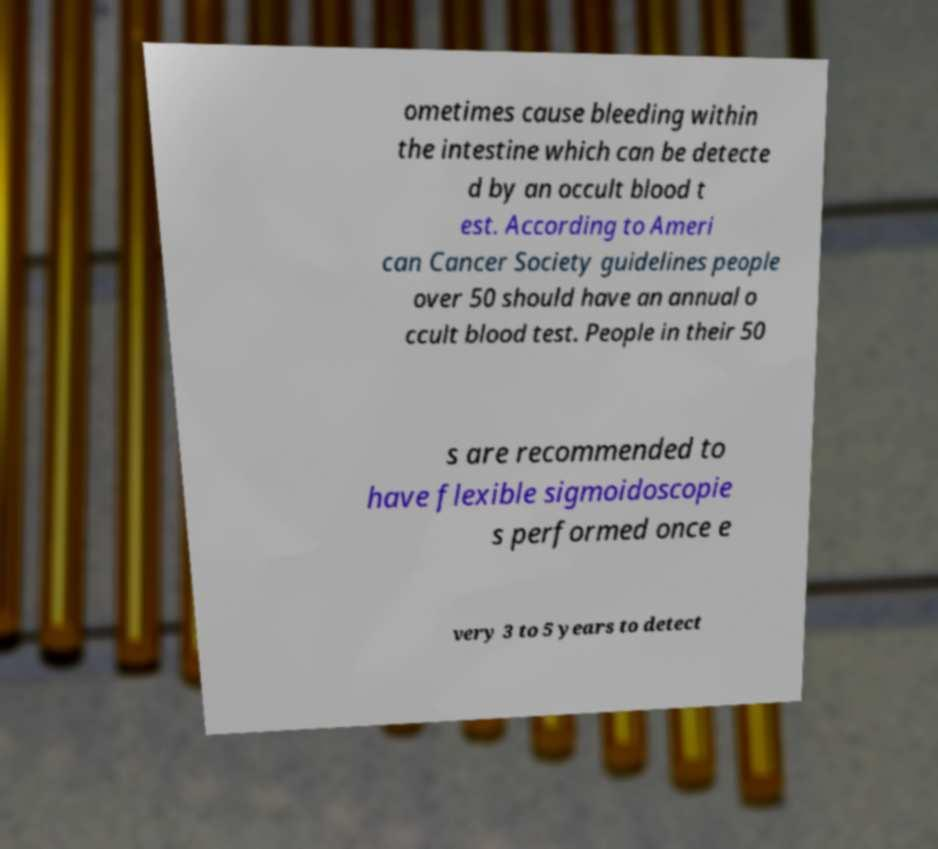For documentation purposes, I need the text within this image transcribed. Could you provide that? ometimes cause bleeding within the intestine which can be detecte d by an occult blood t est. According to Ameri can Cancer Society guidelines people over 50 should have an annual o ccult blood test. People in their 50 s are recommended to have flexible sigmoidoscopie s performed once e very 3 to 5 years to detect 